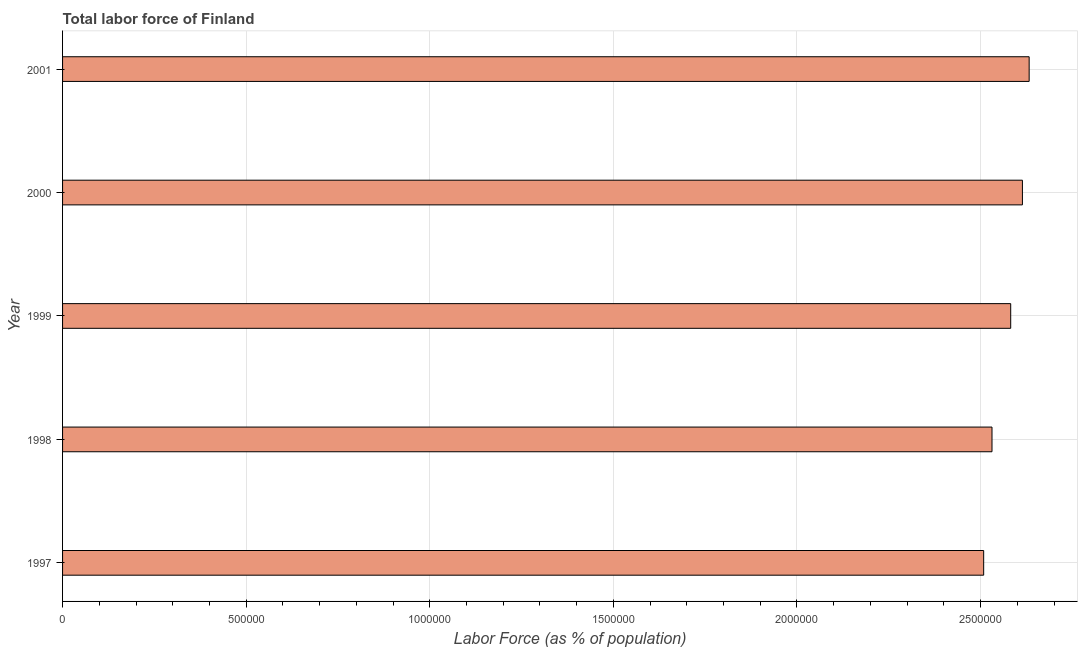What is the title of the graph?
Keep it short and to the point. Total labor force of Finland. What is the label or title of the X-axis?
Your answer should be compact. Labor Force (as % of population). What is the total labor force in 1998?
Keep it short and to the point. 2.53e+06. Across all years, what is the maximum total labor force?
Ensure brevity in your answer.  2.63e+06. Across all years, what is the minimum total labor force?
Offer a terse response. 2.51e+06. In which year was the total labor force maximum?
Ensure brevity in your answer.  2001. In which year was the total labor force minimum?
Provide a short and direct response. 1997. What is the sum of the total labor force?
Provide a succinct answer. 1.29e+07. What is the difference between the total labor force in 1997 and 1999?
Provide a succinct answer. -7.36e+04. What is the average total labor force per year?
Offer a terse response. 2.57e+06. What is the median total labor force?
Keep it short and to the point. 2.58e+06. In how many years, is the total labor force greater than 400000 %?
Give a very brief answer. 5. What is the ratio of the total labor force in 1998 to that in 2000?
Your answer should be very brief. 0.97. Is the total labor force in 1997 less than that in 2000?
Offer a terse response. Yes. Is the difference between the total labor force in 1999 and 2000 greater than the difference between any two years?
Offer a very short reply. No. What is the difference between the highest and the second highest total labor force?
Your answer should be compact. 1.84e+04. Is the sum of the total labor force in 1997 and 1999 greater than the maximum total labor force across all years?
Your answer should be very brief. Yes. What is the difference between the highest and the lowest total labor force?
Your answer should be very brief. 1.24e+05. Are all the bars in the graph horizontal?
Your response must be concise. Yes. Are the values on the major ticks of X-axis written in scientific E-notation?
Your answer should be compact. No. What is the Labor Force (as % of population) in 1997?
Offer a very short reply. 2.51e+06. What is the Labor Force (as % of population) of 1998?
Ensure brevity in your answer.  2.53e+06. What is the Labor Force (as % of population) of 1999?
Ensure brevity in your answer.  2.58e+06. What is the Labor Force (as % of population) in 2000?
Provide a succinct answer. 2.61e+06. What is the Labor Force (as % of population) of 2001?
Your answer should be compact. 2.63e+06. What is the difference between the Labor Force (as % of population) in 1997 and 1998?
Keep it short and to the point. -2.27e+04. What is the difference between the Labor Force (as % of population) in 1997 and 1999?
Your response must be concise. -7.36e+04. What is the difference between the Labor Force (as % of population) in 1997 and 2000?
Your answer should be very brief. -1.06e+05. What is the difference between the Labor Force (as % of population) in 1997 and 2001?
Provide a succinct answer. -1.24e+05. What is the difference between the Labor Force (as % of population) in 1998 and 1999?
Make the answer very short. -5.09e+04. What is the difference between the Labor Force (as % of population) in 1998 and 2000?
Give a very brief answer. -8.28e+04. What is the difference between the Labor Force (as % of population) in 1998 and 2001?
Offer a terse response. -1.01e+05. What is the difference between the Labor Force (as % of population) in 1999 and 2000?
Provide a short and direct response. -3.19e+04. What is the difference between the Labor Force (as % of population) in 1999 and 2001?
Ensure brevity in your answer.  -5.03e+04. What is the difference between the Labor Force (as % of population) in 2000 and 2001?
Your answer should be compact. -1.84e+04. What is the ratio of the Labor Force (as % of population) in 1997 to that in 1999?
Provide a succinct answer. 0.97. What is the ratio of the Labor Force (as % of population) in 1997 to that in 2000?
Your answer should be compact. 0.96. What is the ratio of the Labor Force (as % of population) in 1997 to that in 2001?
Ensure brevity in your answer.  0.95. What is the ratio of the Labor Force (as % of population) in 1999 to that in 2000?
Your response must be concise. 0.99. 